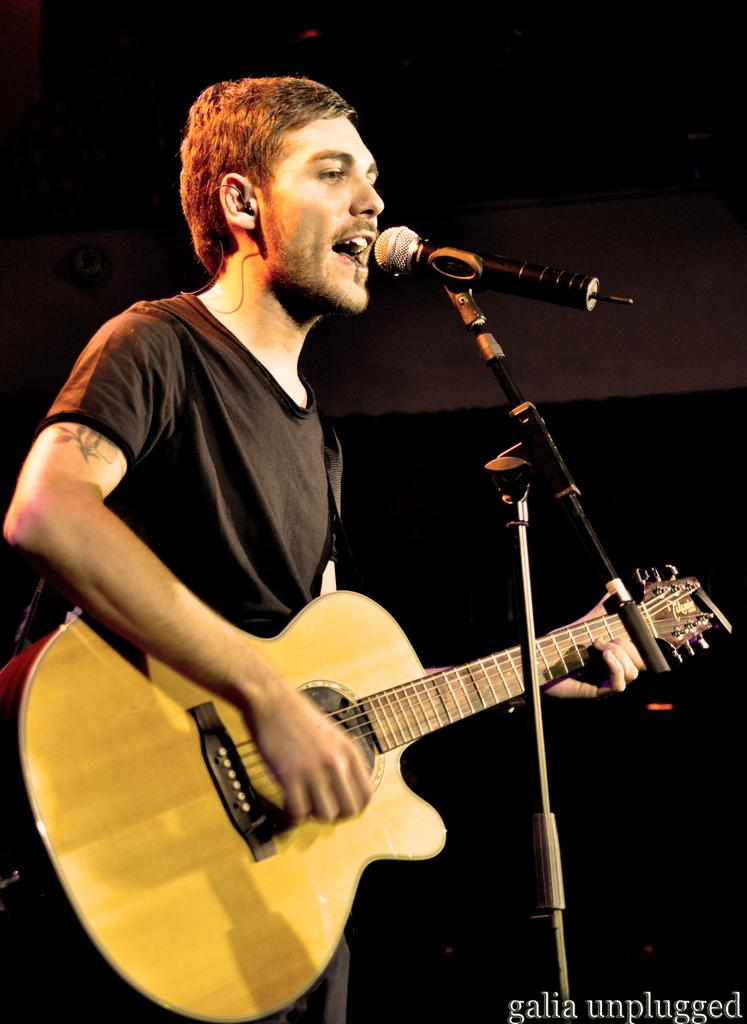What is the main subject of the image? The main subject of the image is a man. What is the man doing in the image? The man is standing, singing, and holding a microphone and a guitar. What type of horse can be seen in the image? There is no horse present in the image; the main subject is a man holding a microphone and a guitar. What color is the crow in the image? There is no crow present in the image; the main subject is a man holding a microphone and a guitar. 